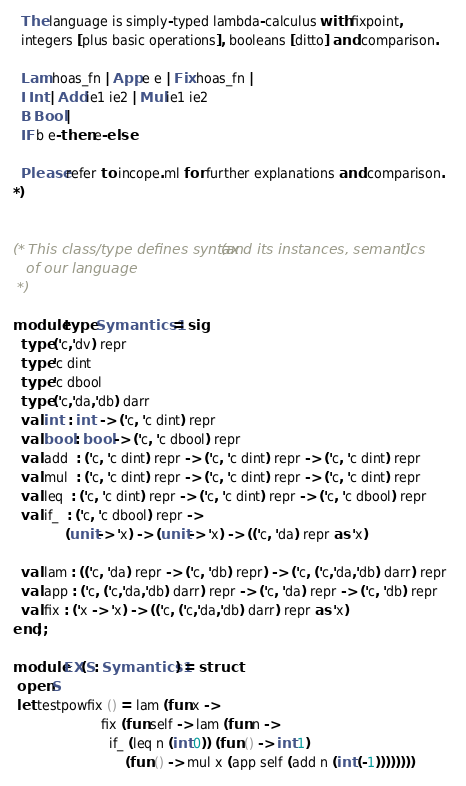Convert code to text. <code><loc_0><loc_0><loc_500><loc_500><_OCaml_>  The language is simply-typed lambda-calculus with fixpoint,
  integers [plus basic operations], booleans [ditto] and comparison.

  Lam hoas_fn | App e e | Fix hoas_fn |
  I Int | Add ie1 ie2 | Mul ie1 ie2 
  B Bool |
  IF b e-then e-else

  Please refer to incope.ml for further explanations and comparison.  
*)


(* This class/type defines syntax (and its instances, semantics) 
   of our language
 *)

module type Symantics1 = sig
  type ('c,'dv) repr
  type 'c dint
  type 'c dbool
  type ('c,'da,'db) darr
  val int  : int  -> ('c, 'c dint) repr
  val bool : bool -> ('c, 'c dbool) repr
  val add  : ('c, 'c dint) repr -> ('c, 'c dint) repr -> ('c, 'c dint) repr
  val mul  : ('c, 'c dint) repr -> ('c, 'c dint) repr -> ('c, 'c dint) repr
  val leq  : ('c, 'c dint) repr -> ('c, 'c dint) repr -> ('c, 'c dbool) repr
  val if_  : ('c, 'c dbool) repr ->
             (unit -> 'x) -> (unit -> 'x) -> (('c, 'da) repr as 'x)

  val lam : (('c, 'da) repr -> ('c, 'db) repr) -> ('c, ('c,'da,'db) darr) repr
  val app : ('c, ('c,'da,'db) darr) repr -> ('c, 'da) repr -> ('c, 'db) repr
  val fix : ('x -> 'x) -> (('c, ('c,'da,'db) darr) repr as 'x)
end;;

module EX(S: Symantics1) = struct
 open S
 let testpowfix () = lam (fun x ->
                      fix (fun self -> lam (fun n ->
                        if_ (leq n (int 0)) (fun () -> int 1)
                            (fun () -> mul x (app self (add n (int (-1))))))))</code> 